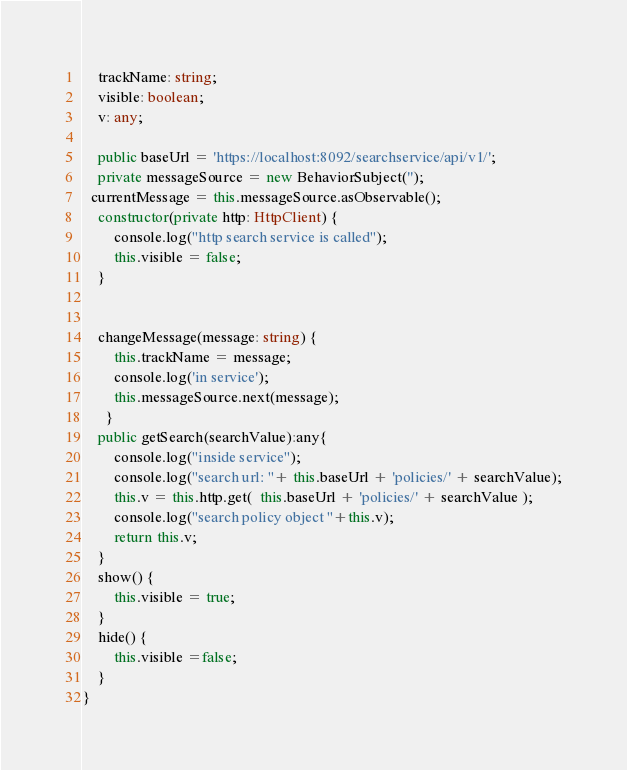Convert code to text. <code><loc_0><loc_0><loc_500><loc_500><_TypeScript_>    trackName: string;
    visible: boolean;
    v: any;
    
    public baseUrl = 'https://localhost:8092/searchservice/api/v1/';
    private messageSource = new BehaviorSubject('');
  currentMessage = this.messageSource.asObservable();
    constructor(private http: HttpClient) {
        console.log("http search service is called");
        this.visible = false;
    }

   
    changeMessage(message: string) {
        this.trackName = message;
        console.log('in service');
        this.messageSource.next(message);
      }
    public getSearch(searchValue):any{
        console.log("inside service");
        console.log("search url: "+ this.baseUrl + 'policies/' + searchValue);
        this.v = this.http.get(  this.baseUrl + 'policies/' + searchValue );
        console.log("search policy object "+this.v);
        return this.v;
    }
    show() {
        this.visible = true;
    }
    hide() {
        this.visible =false;
    }
}
</code> 